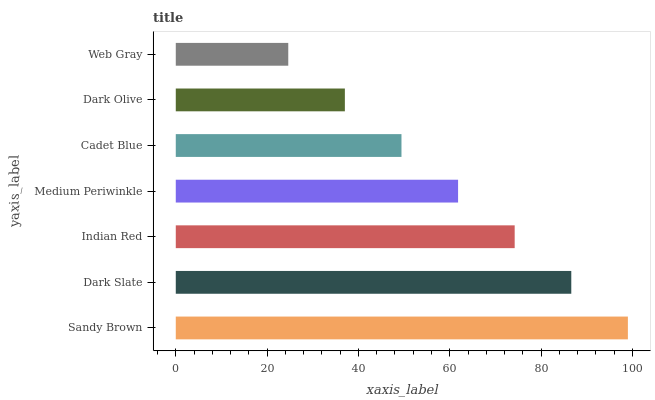Is Web Gray the minimum?
Answer yes or no. Yes. Is Sandy Brown the maximum?
Answer yes or no. Yes. Is Dark Slate the minimum?
Answer yes or no. No. Is Dark Slate the maximum?
Answer yes or no. No. Is Sandy Brown greater than Dark Slate?
Answer yes or no. Yes. Is Dark Slate less than Sandy Brown?
Answer yes or no. Yes. Is Dark Slate greater than Sandy Brown?
Answer yes or no. No. Is Sandy Brown less than Dark Slate?
Answer yes or no. No. Is Medium Periwinkle the high median?
Answer yes or no. Yes. Is Medium Periwinkle the low median?
Answer yes or no. Yes. Is Web Gray the high median?
Answer yes or no. No. Is Indian Red the low median?
Answer yes or no. No. 